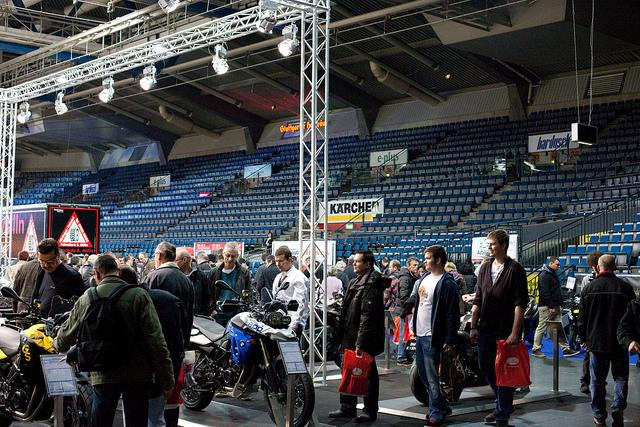What type of vehicle are the people looking at? motorcycle 